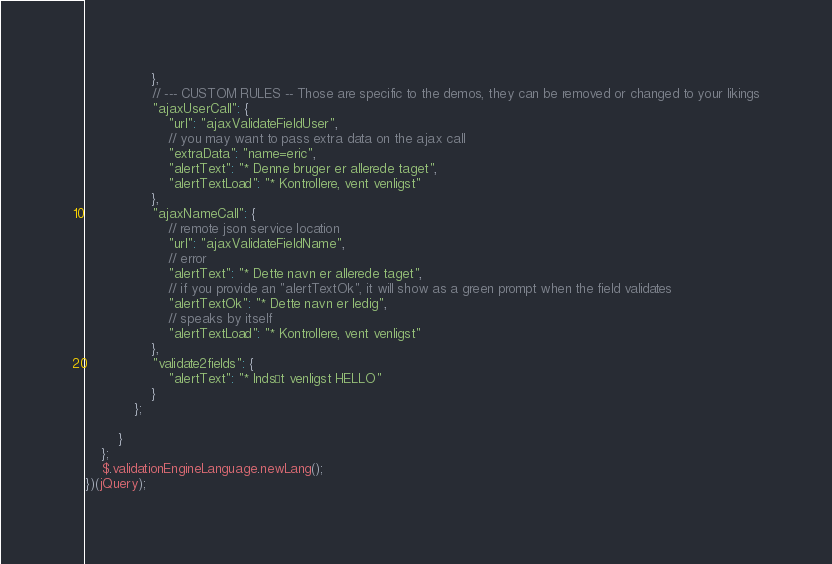<code> <loc_0><loc_0><loc_500><loc_500><_JavaScript_>                },
                // --- CUSTOM RULES -- Those are specific to the demos, they can be removed or changed to your likings
                "ajaxUserCall": {
                    "url": "ajaxValidateFieldUser",
                    // you may want to pass extra data on the ajax call
                    "extraData": "name=eric",
                    "alertText": "* Denne bruger er allerede taget",
                    "alertTextLoad": "* Kontrollere, vent venligst"
                },
                "ajaxNameCall": {
                    // remote json service location
                    "url": "ajaxValidateFieldName",
                    // error
                    "alertText": "* Dette navn er allerede taget",
                    // if you provide an "alertTextOk", it will show as a green prompt when the field validates
                    "alertTextOk": "* Dette navn er ledig",
                    // speaks by itself
                    "alertTextLoad": "* Kontrollere, vent venligst"
                },
                "validate2fields": {
                    "alertText": "* Indsæt venligst HELLO"
                }
            };
            
        }
    };
    $.validationEngineLanguage.newLang();
})(jQuery);</code> 